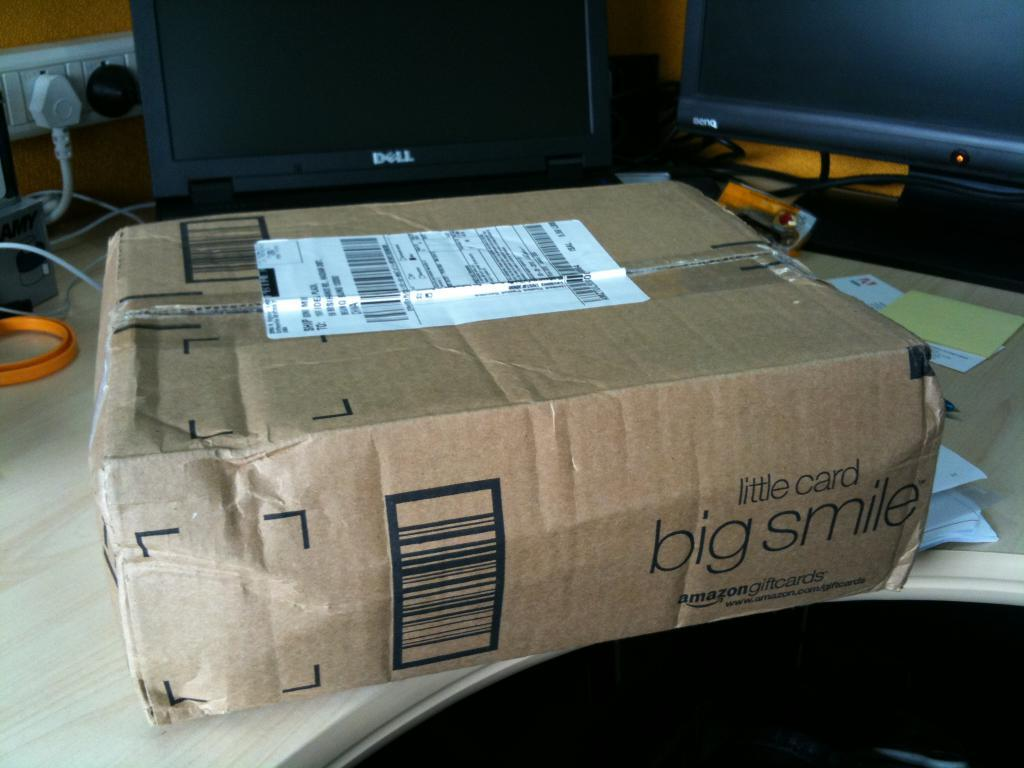Provide a one-sentence caption for the provided image. A brown package that says little card big smile on the side sitting on a table with a computer behind it. 